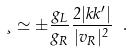Convert formula to latex. <formula><loc_0><loc_0><loc_500><loc_500>\xi \simeq \pm \frac { g _ { L } } { g _ { R } } \frac { 2 | k k ^ { \prime } | } { | v _ { R } | ^ { 2 } } \ .</formula> 